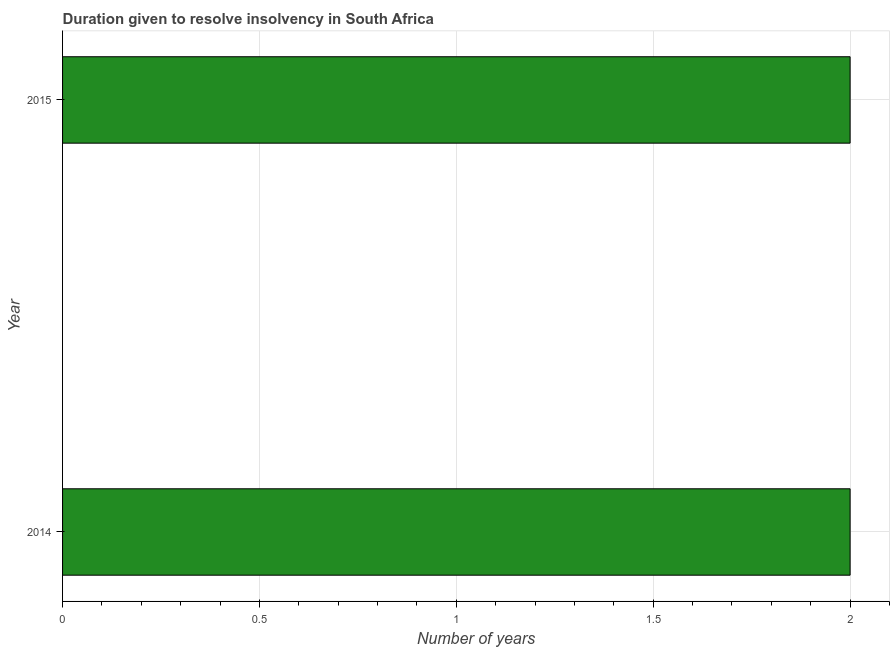Does the graph contain any zero values?
Provide a succinct answer. No. What is the title of the graph?
Your response must be concise. Duration given to resolve insolvency in South Africa. What is the label or title of the X-axis?
Offer a very short reply. Number of years. What is the label or title of the Y-axis?
Keep it short and to the point. Year. What is the number of years to resolve insolvency in 2015?
Make the answer very short. 2. Across all years, what is the minimum number of years to resolve insolvency?
Offer a very short reply. 2. In which year was the number of years to resolve insolvency maximum?
Your answer should be compact. 2014. What is the sum of the number of years to resolve insolvency?
Your response must be concise. 4. What is the difference between the number of years to resolve insolvency in 2014 and 2015?
Provide a short and direct response. 0. What is the median number of years to resolve insolvency?
Provide a succinct answer. 2. In how many years, is the number of years to resolve insolvency greater than 1 ?
Give a very brief answer. 2. Is the number of years to resolve insolvency in 2014 less than that in 2015?
Your answer should be very brief. No. In how many years, is the number of years to resolve insolvency greater than the average number of years to resolve insolvency taken over all years?
Give a very brief answer. 0. How many bars are there?
Keep it short and to the point. 2. Are all the bars in the graph horizontal?
Provide a succinct answer. Yes. Are the values on the major ticks of X-axis written in scientific E-notation?
Keep it short and to the point. No. What is the Number of years in 2014?
Make the answer very short. 2. What is the Number of years of 2015?
Your answer should be very brief. 2. What is the difference between the Number of years in 2014 and 2015?
Offer a very short reply. 0. What is the ratio of the Number of years in 2014 to that in 2015?
Your response must be concise. 1. 